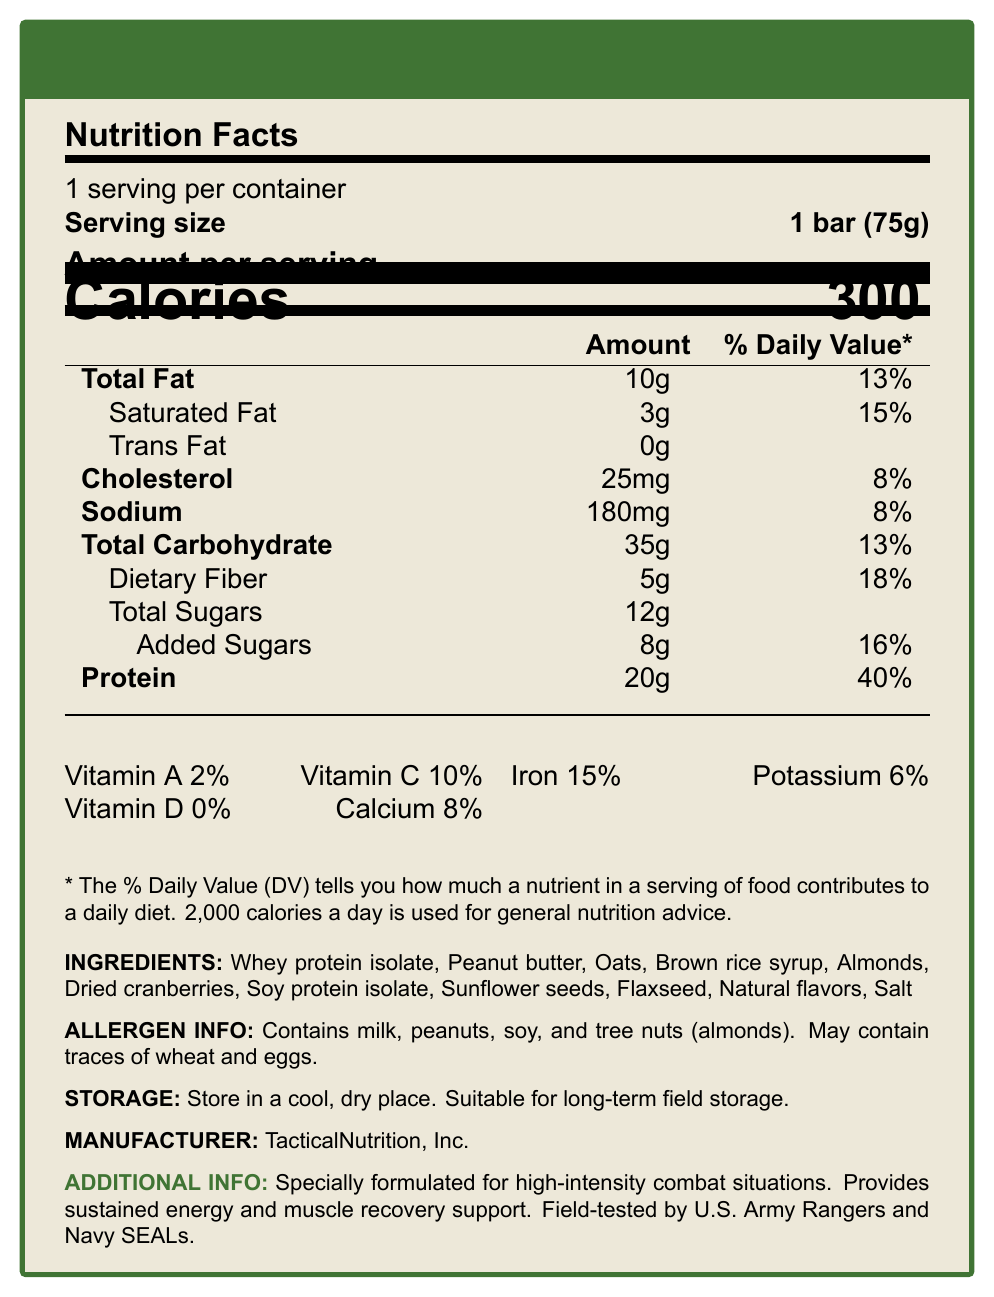what is the serving size of the Combat Warrior Energy Bar? The serving size is clearly indicated as "1 bar (75g)" in the Nutrition Facts section.
Answer: 1 bar (75g) how many calories are there per serving? The Calories per serving is displayed as 300 right below the Amount per serving header.
Answer: 300 how much protein does the Combat Warrior Energy Bar contain? The protein content is listed as 20g in the table of nutrients.
Answer: 20g name one of the ingredients of the Combat Warrior Energy Bar. One of the listed ingredients is "Whey protein isolate".
Answer: Whey protein isolate what percentage of daily value of dietary fiber is provided by one bar? The daily value percentage for dietary fiber is listed as "18%" in the nutrient table.
Answer: 18% how long can the Combat Warrior Energy Bar be stored in the field? A. 1 month B. 6 months C. Long-term D. 1 year The storage instructions specify "Suitable for long-term field storage".
Answer: C. Long-term which of these allergens are present in the Combat Warrior Energy Bar? I. Milk II. Wheat III. Tree nuts IV. Eggs The allergen information section states the bar contains milk and tree nuts.
Answer: I and III how much sugar is present in one serving, including added sugars? A. 5g B. 8g C. 12g D. 20g The total sugars are listed as 12g, with added sugars being 8g included in this total.
Answer: C. 12g should the Combat Warrior Energy Bar be stored in a refrigerated environment? A. Yes B. No The storage instructions say to store in a cool, dry place but do not specify refrigeration.
Answer: B. No was this energy bar field-tested by U.S. Navy SEALs? The additional information mentions that the bar was field-tested by U.S. Army Rangers and Navy SEALs.
Answer: Yes can the exact number of bars per container be determined from the document? The document specifies "1 serving per container".
Answer: Yes does the Combat Warrior Energy Bar contain artificial flavors? The ingredient list specifies "Natural flavors," indicating no artificial flavors are used.
Answer: No why might the Combat Warrior Energy Bar be suitable for combat situations? The additional information mentions the bar is specially formulated for high-intensity combat situations, providing sustained energy and muscle recovery support due to its high protein content and other nutrients.
Answer: High protein content and sustained energy which vitamins are present in significant amounts in the Combat Warrior Energy Bar? A. Vitamin A and Vitamin C B. Vitamin B and Vitamin E C. Vitamin D and Vitamin K The document lists Vitamin A as 2% and Vitamin C as 10%. Other vitamins such as D and B are either minimal or not mentioned.
Answer: A. Vitamin A and Vitamin C what is the main purpose of the document? The main purpose of the document is to describe the nutritional content, ingredients, allergen information, and utility of the Combat Warrior Energy Bar, as well as its suitability for high-intensity combat situations.
Answer: To provide detailed nutritional information about the Combat Warrior Energy Bar how much trans fat does the Combat Warrior Energy Bar contain per serving? The document states that there are 0g of trans fat per serving.
Answer: 0g is the document visually appealing and easy to read? The document uses clear headings, tables, and bullet points to convey information effectively.
Answer: Yes 